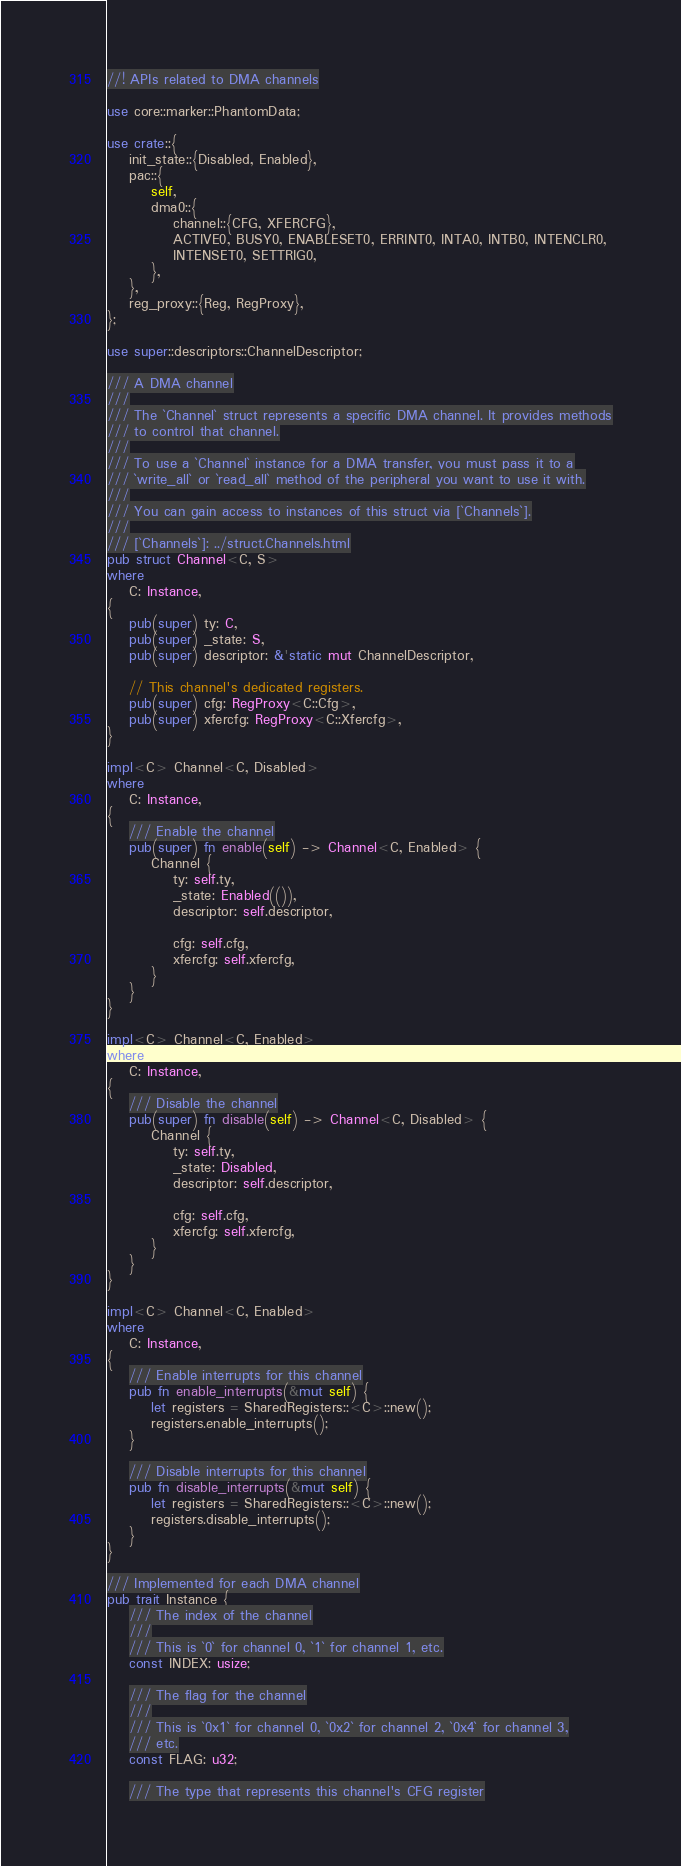Convert code to text. <code><loc_0><loc_0><loc_500><loc_500><_Rust_>//! APIs related to DMA channels

use core::marker::PhantomData;

use crate::{
    init_state::{Disabled, Enabled},
    pac::{
        self,
        dma0::{
            channel::{CFG, XFERCFG},
            ACTIVE0, BUSY0, ENABLESET0, ERRINT0, INTA0, INTB0, INTENCLR0,
            INTENSET0, SETTRIG0,
        },
    },
    reg_proxy::{Reg, RegProxy},
};

use super::descriptors::ChannelDescriptor;

/// A DMA channel
///
/// The `Channel` struct represents a specific DMA channel. It provides methods
/// to control that channel.
///
/// To use a `Channel` instance for a DMA transfer, you must pass it to a
/// `write_all` or `read_all` method of the peripheral you want to use it with.
///
/// You can gain access to instances of this struct via [`Channels`].
///
/// [`Channels`]: ../struct.Channels.html
pub struct Channel<C, S>
where
    C: Instance,
{
    pub(super) ty: C,
    pub(super) _state: S,
    pub(super) descriptor: &'static mut ChannelDescriptor,

    // This channel's dedicated registers.
    pub(super) cfg: RegProxy<C::Cfg>,
    pub(super) xfercfg: RegProxy<C::Xfercfg>,
}

impl<C> Channel<C, Disabled>
where
    C: Instance,
{
    /// Enable the channel
    pub(super) fn enable(self) -> Channel<C, Enabled> {
        Channel {
            ty: self.ty,
            _state: Enabled(()),
            descriptor: self.descriptor,

            cfg: self.cfg,
            xfercfg: self.xfercfg,
        }
    }
}

impl<C> Channel<C, Enabled>
where
    C: Instance,
{
    /// Disable the channel
    pub(super) fn disable(self) -> Channel<C, Disabled> {
        Channel {
            ty: self.ty,
            _state: Disabled,
            descriptor: self.descriptor,

            cfg: self.cfg,
            xfercfg: self.xfercfg,
        }
    }
}

impl<C> Channel<C, Enabled>
where
    C: Instance,
{
    /// Enable interrupts for this channel
    pub fn enable_interrupts(&mut self) {
        let registers = SharedRegisters::<C>::new();
        registers.enable_interrupts();
    }

    /// Disable interrupts for this channel
    pub fn disable_interrupts(&mut self) {
        let registers = SharedRegisters::<C>::new();
        registers.disable_interrupts();
    }
}

/// Implemented for each DMA channel
pub trait Instance {
    /// The index of the channel
    ///
    /// This is `0` for channel 0, `1` for channel 1, etc.
    const INDEX: usize;

    /// The flag for the channel
    ///
    /// This is `0x1` for channel 0, `0x2` for channel 2, `0x4` for channel 3,
    /// etc.
    const FLAG: u32;

    /// The type that represents this channel's CFG register</code> 